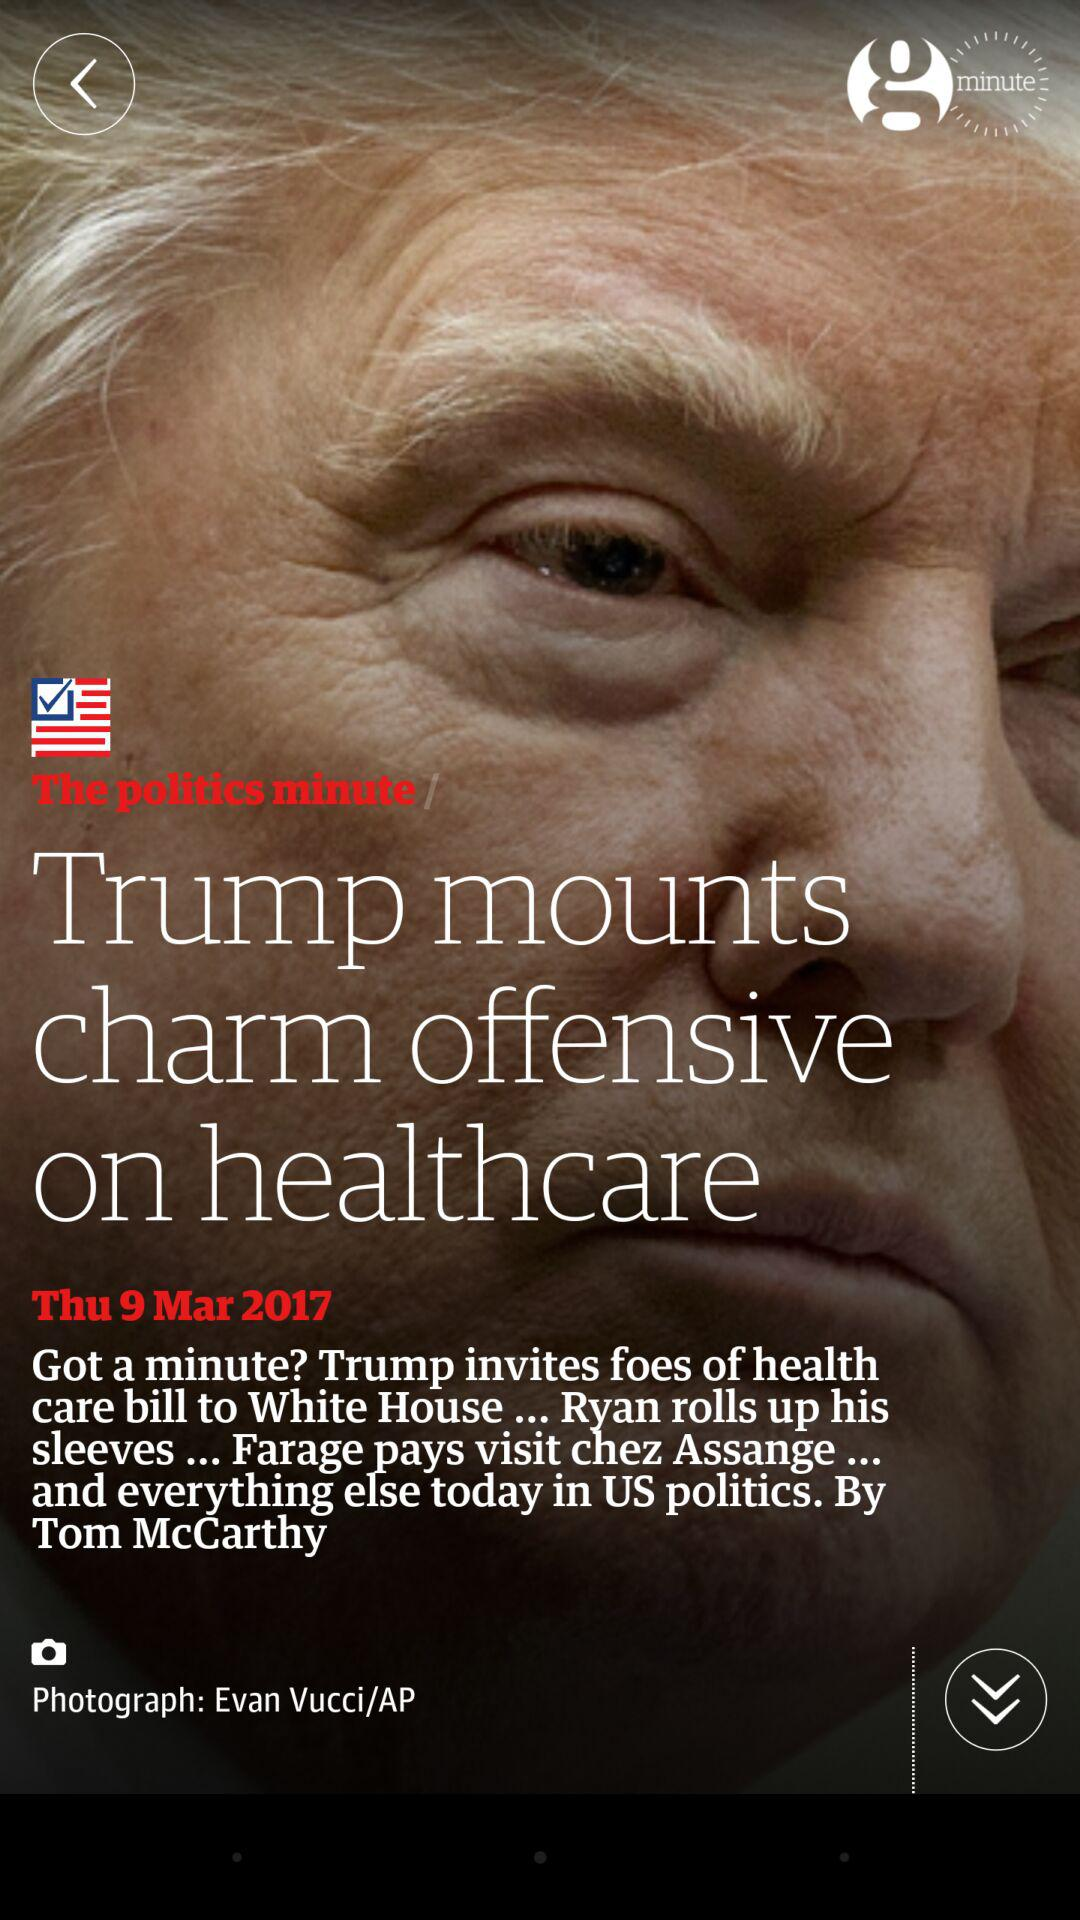What is the writer's name? The writer's name is Tom McCarthy. 